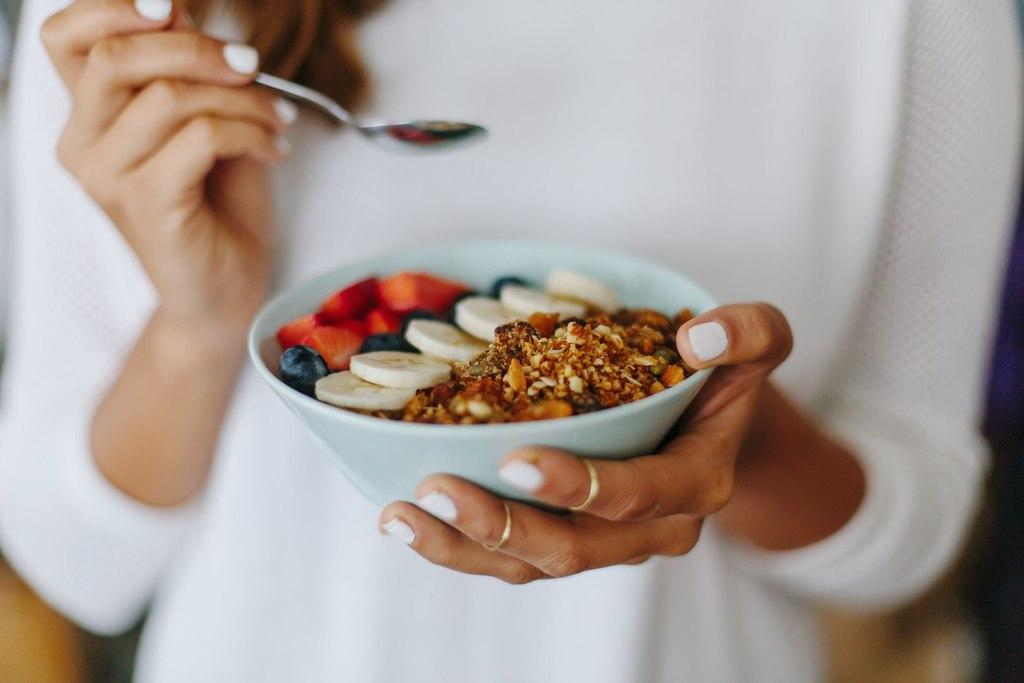What is the main subject of the image? There is a person in the image. What is the person holding in the image? The person is holding a bowl with food items in it and a spoon. Can you describe the background of the image? The background of the image is blurry. What type of lettuce can be seen in the game that the person is playing in the image? There is no game or lettuce present in the image; it features a person holding a bowl with food items and a spoon. Can you tell me how many socks the person is wearing in the image? There is no information about socks in the image; it only shows a person holding a bowl with food items and a spoon. 